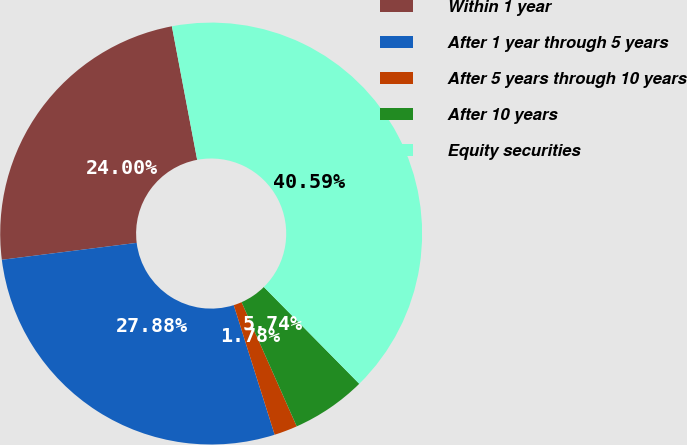Convert chart to OTSL. <chart><loc_0><loc_0><loc_500><loc_500><pie_chart><fcel>Within 1 year<fcel>After 1 year through 5 years<fcel>After 5 years through 10 years<fcel>After 10 years<fcel>Equity securities<nl><fcel>24.0%<fcel>27.88%<fcel>1.78%<fcel>5.74%<fcel>40.59%<nl></chart> 